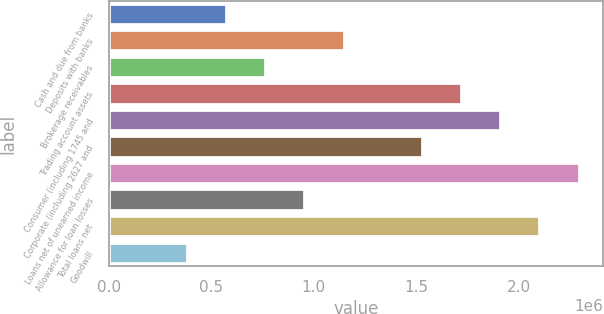Convert chart to OTSL. <chart><loc_0><loc_0><loc_500><loc_500><bar_chart><fcel>Cash and due from banks<fcel>Deposits with banks<fcel>Brokerage receivables<fcel>Trading account assets<fcel>Consumer (including 1745 and<fcel>Corporate (including 2627 and<fcel>Loans net of unearned income<fcel>Allowance for loan losses<fcel>Total loans net<fcel>Goodwill<nl><fcel>577358<fcel>1.15016e+06<fcel>768293<fcel>1.72297e+06<fcel>1.9139e+06<fcel>1.53203e+06<fcel>2.29577e+06<fcel>959228<fcel>2.10484e+06<fcel>386424<nl></chart> 